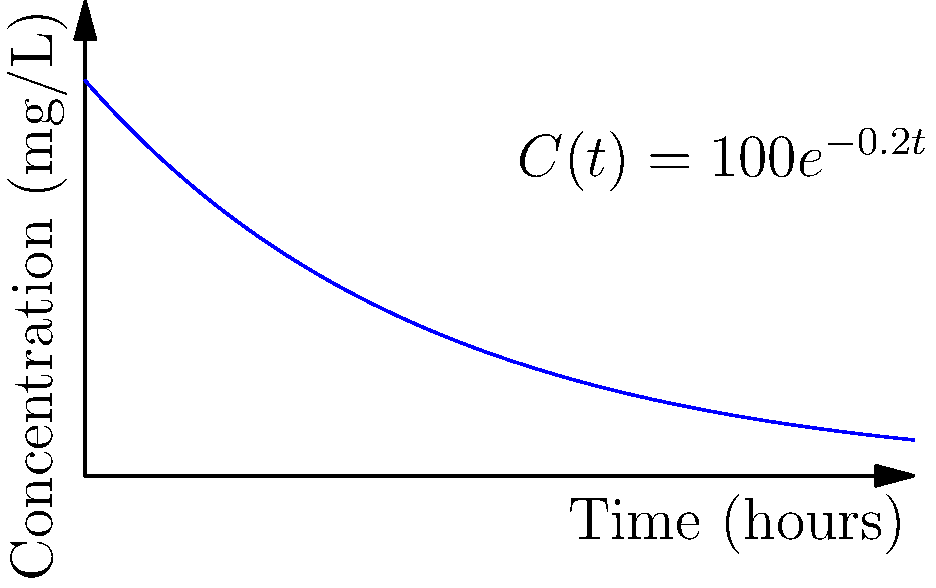As a family doctor, you're monitoring a patient's medication levels. The concentration-time curve for a drug in the patient's bloodstream is given by $C(t) = 100e^{-0.2t}$, where $C$ is the concentration in mg/L and $t$ is time in hours. At what time does the rate of change of the drug concentration reach -10 mg/L/hour? To solve this problem, we need to follow these steps:

1) First, we need to find the derivative of the concentration function $C(t)$:
   $C(t) = 100e^{-0.2t}$
   $C'(t) = 100 \cdot (-0.2) \cdot e^{-0.2t} = -20e^{-0.2t}$

2) The question asks when the rate of change (which is the derivative) equals -10 mg/L/hour:
   $C'(t) = -10$

3) Now we can set up an equation:
   $-20e^{-0.2t} = -10$

4) Divide both sides by -20:
   $e^{-0.2t} = 0.5$

5) Take the natural log of both sides:
   $-0.2t = \ln(0.5)$

6) Solve for t:
   $t = -\frac{\ln(0.5)}{0.2} = \frac{\ln(2)}{0.2} \approx 3.47$ hours

Therefore, the rate of change of the drug concentration reaches -10 mg/L/hour after approximately 3.47 hours.
Answer: 3.47 hours 